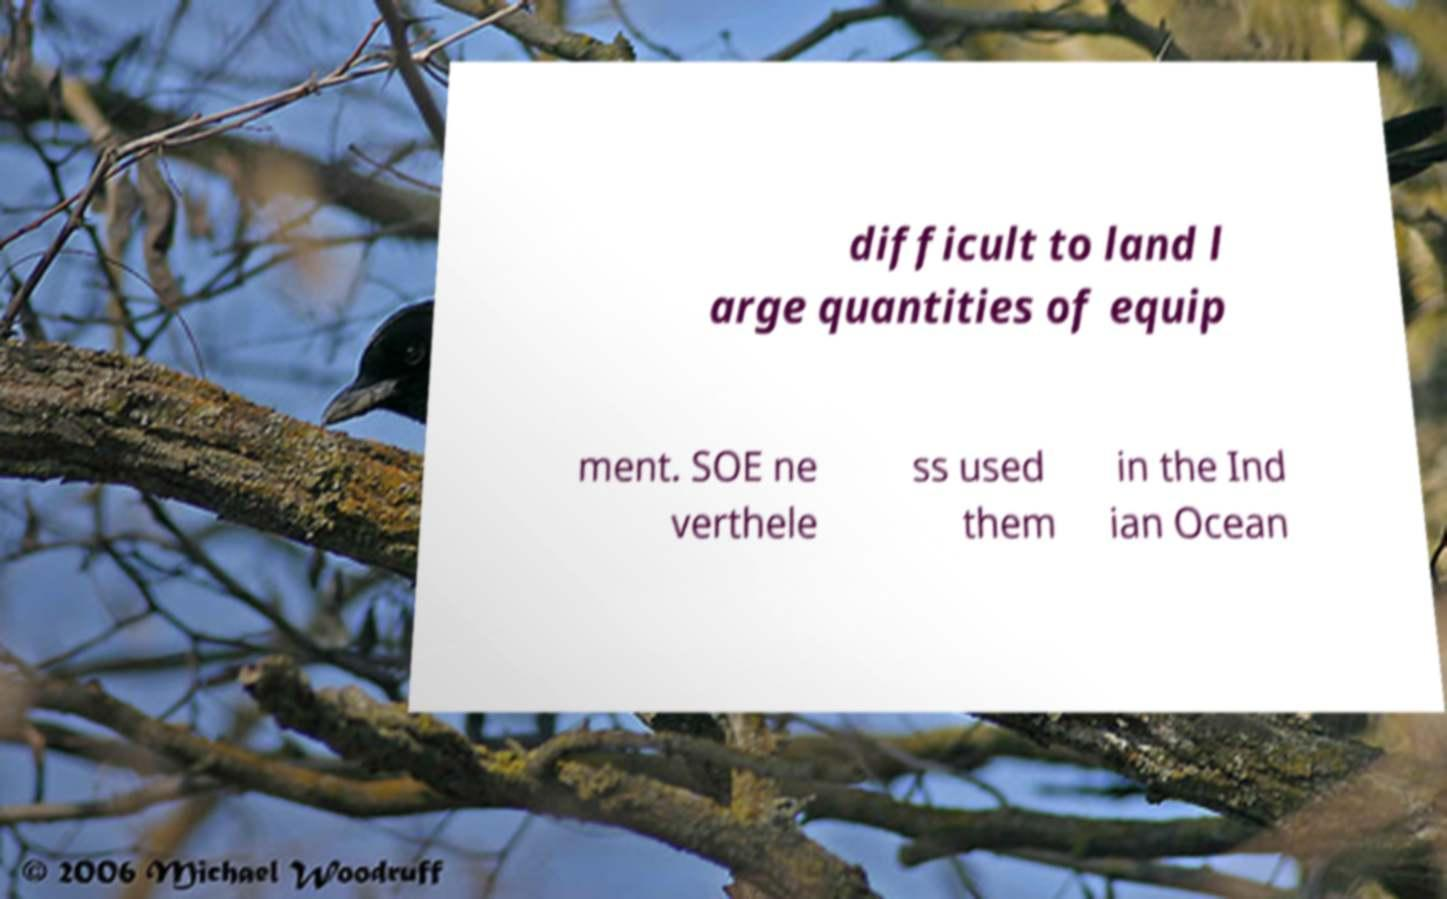Please identify and transcribe the text found in this image. difficult to land l arge quantities of equip ment. SOE ne verthele ss used them in the Ind ian Ocean 